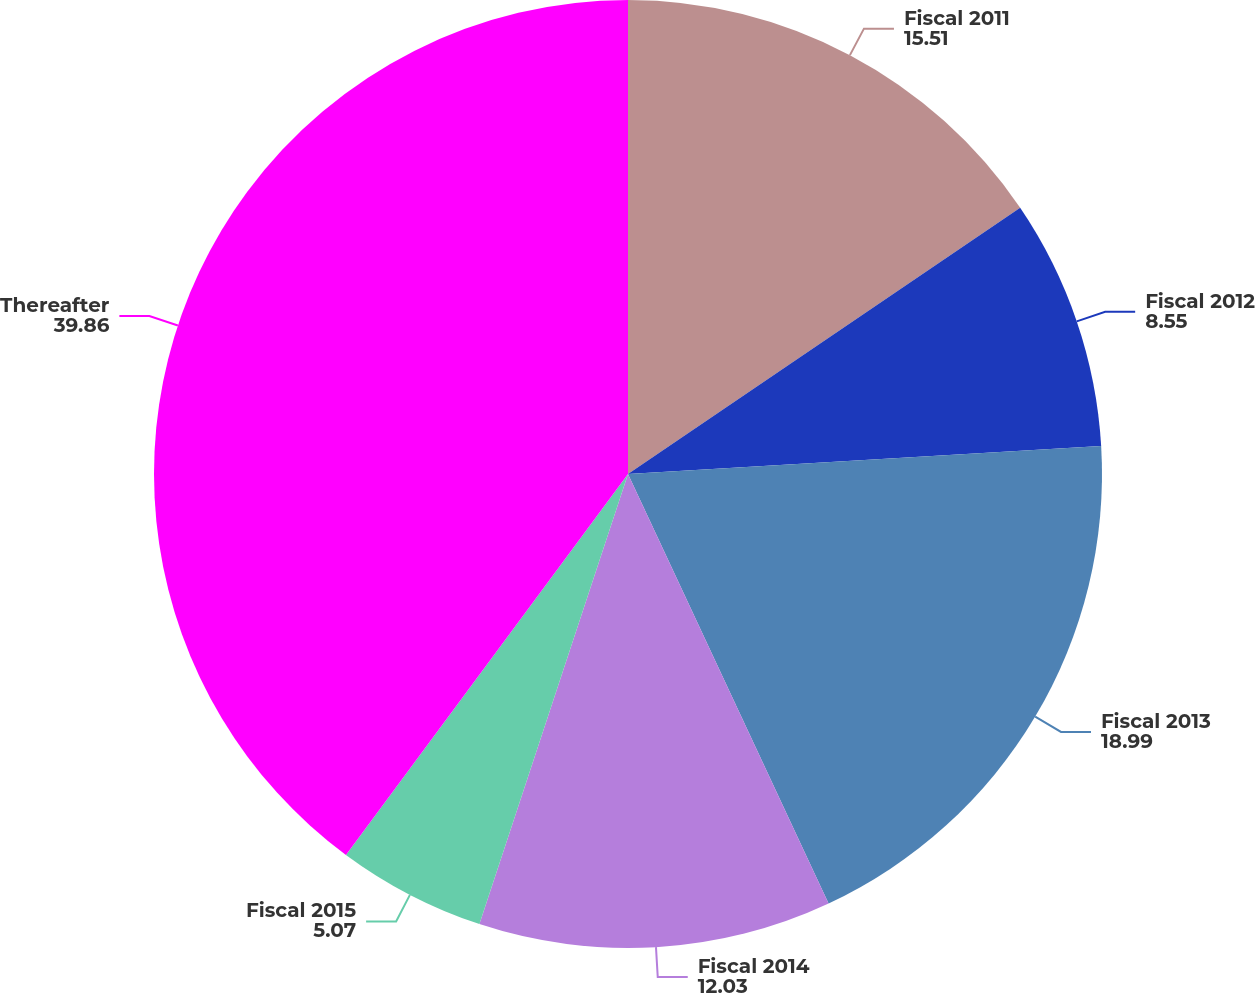Convert chart to OTSL. <chart><loc_0><loc_0><loc_500><loc_500><pie_chart><fcel>Fiscal 2011<fcel>Fiscal 2012<fcel>Fiscal 2013<fcel>Fiscal 2014<fcel>Fiscal 2015<fcel>Thereafter<nl><fcel>15.51%<fcel>8.55%<fcel>18.99%<fcel>12.03%<fcel>5.07%<fcel>39.86%<nl></chart> 